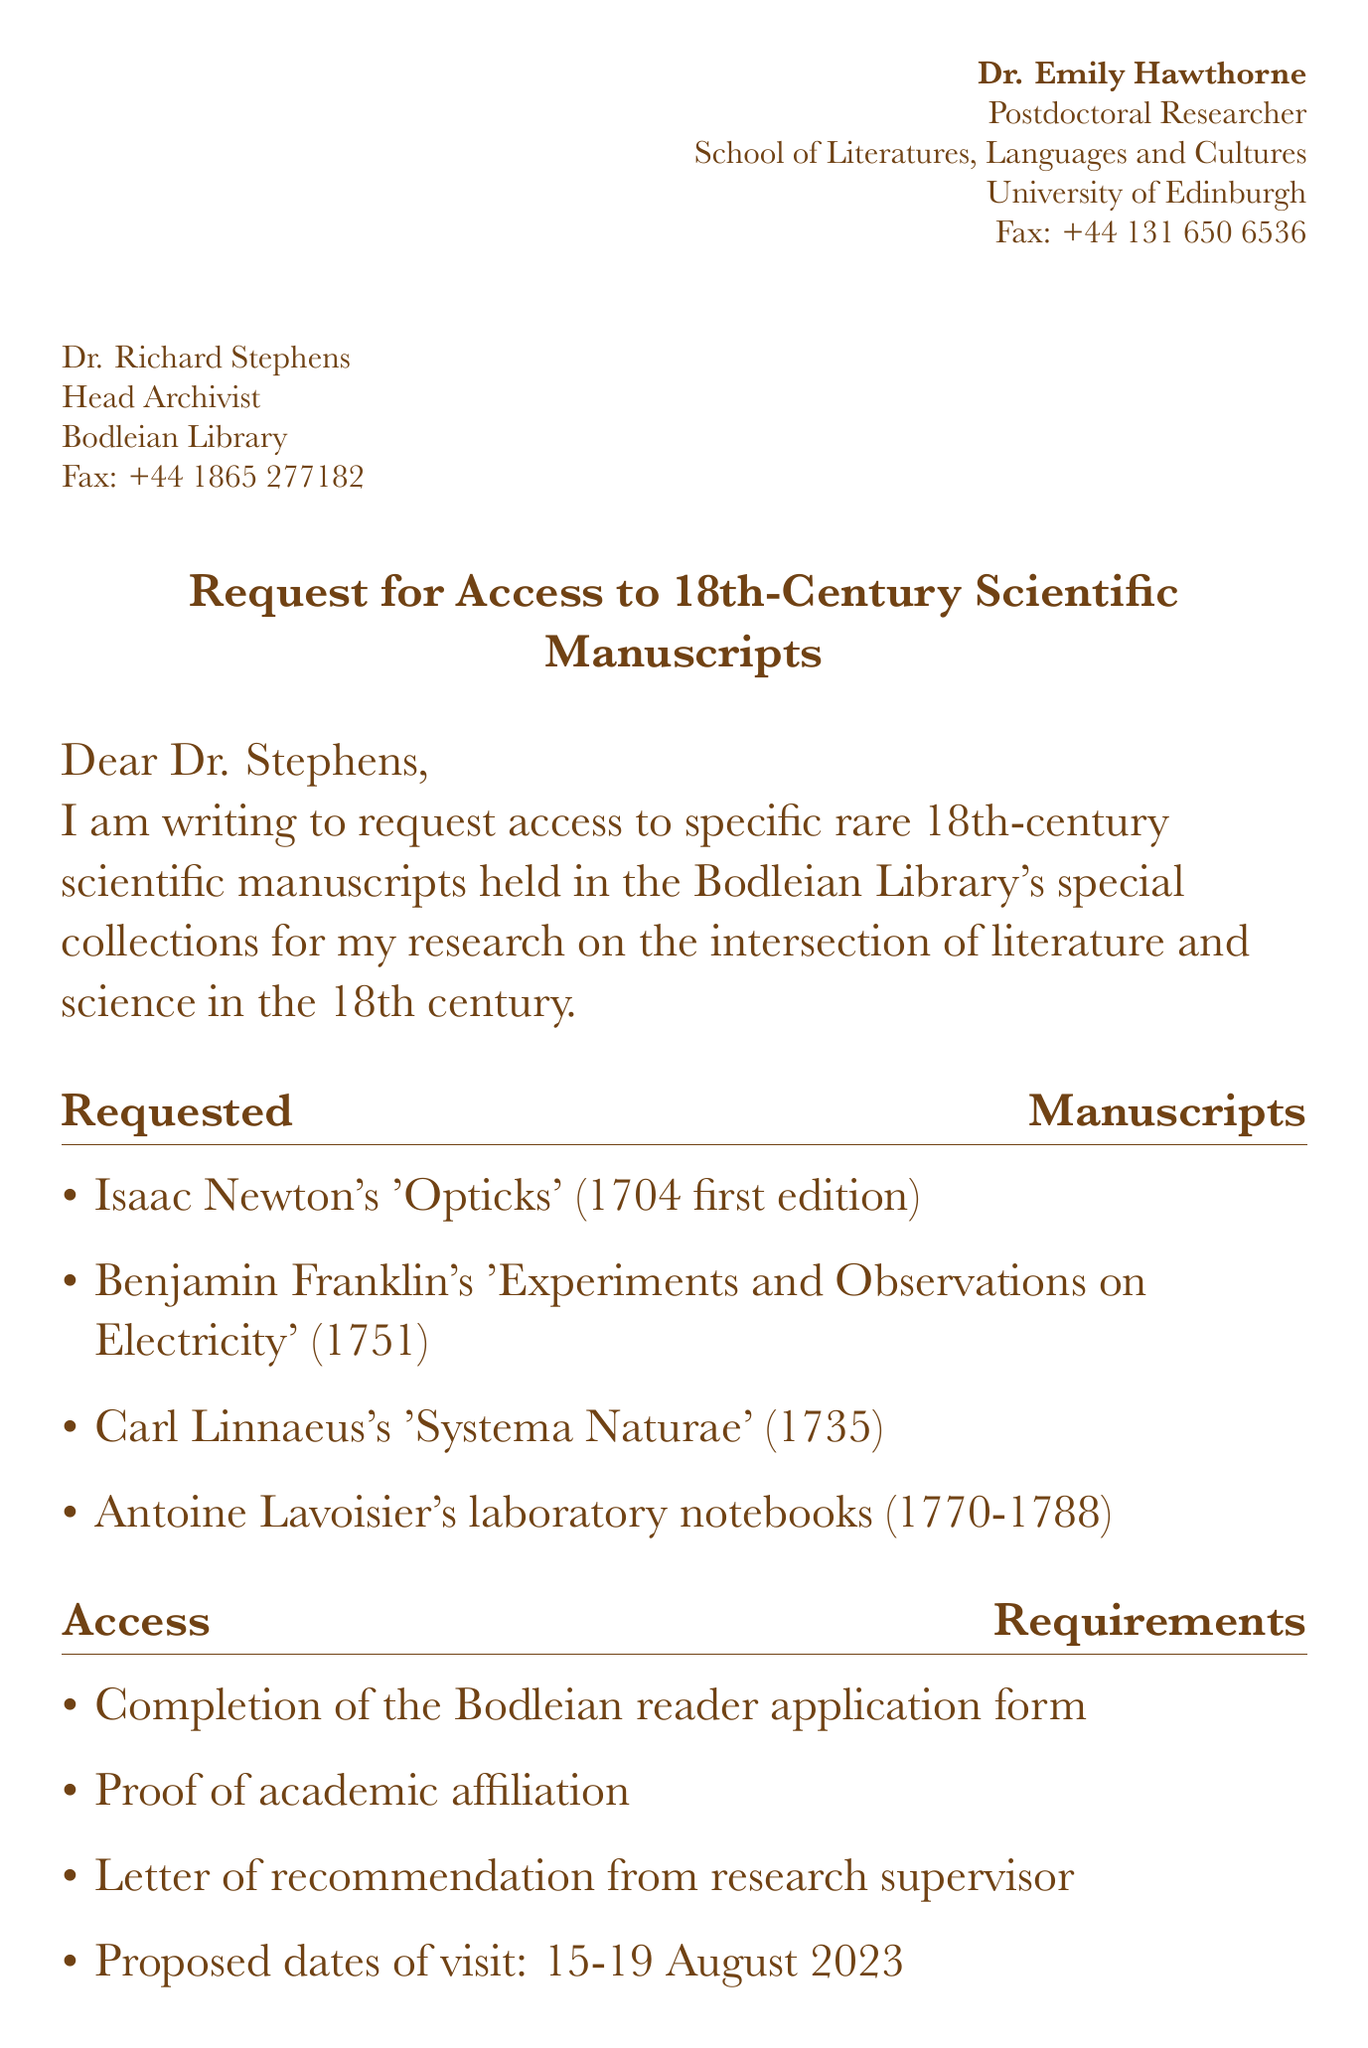What is the name of the sender? The sender is identified as Dr. Emily Hawthorne in the document.
Answer: Dr. Emily Hawthorne Who is the recipient of the fax? The recipient of the fax is Dr. Richard Stephens, the Head Archivist at the Bodleian Library.
Answer: Dr. Richard Stephens What is the title of the requested Isaac Newton manuscript? The title of the requested Isaac Newton manuscript is 'Opticks'.
Answer: 'Opticks' In what year was Benjamin Franklin's manuscript published? The manuscript by Benjamin Franklin was published in 1751.
Answer: 1751 What are the proposed dates of the visit? The proposed dates of the visit are specified in the document as August 15-19, 2023.
Answer: 15-19 August 2023 What type of permission is requested for photographs? The researcher requests permission to take non-flash photographs for research purposes.
Answer: non-flash photographs What proof is required for access? The researcher must provide proof of academic affiliation to access the manuscripts.
Answer: Proof of academic affiliation What is the first edition year of 'Systema Naturae'? The first edition year of 'Systema Naturae' is 1735.
Answer: 1735 What additional service is requested from the library? The researcher requests access to the library's digital scanning services for select pages.
Answer: digital scanning services 